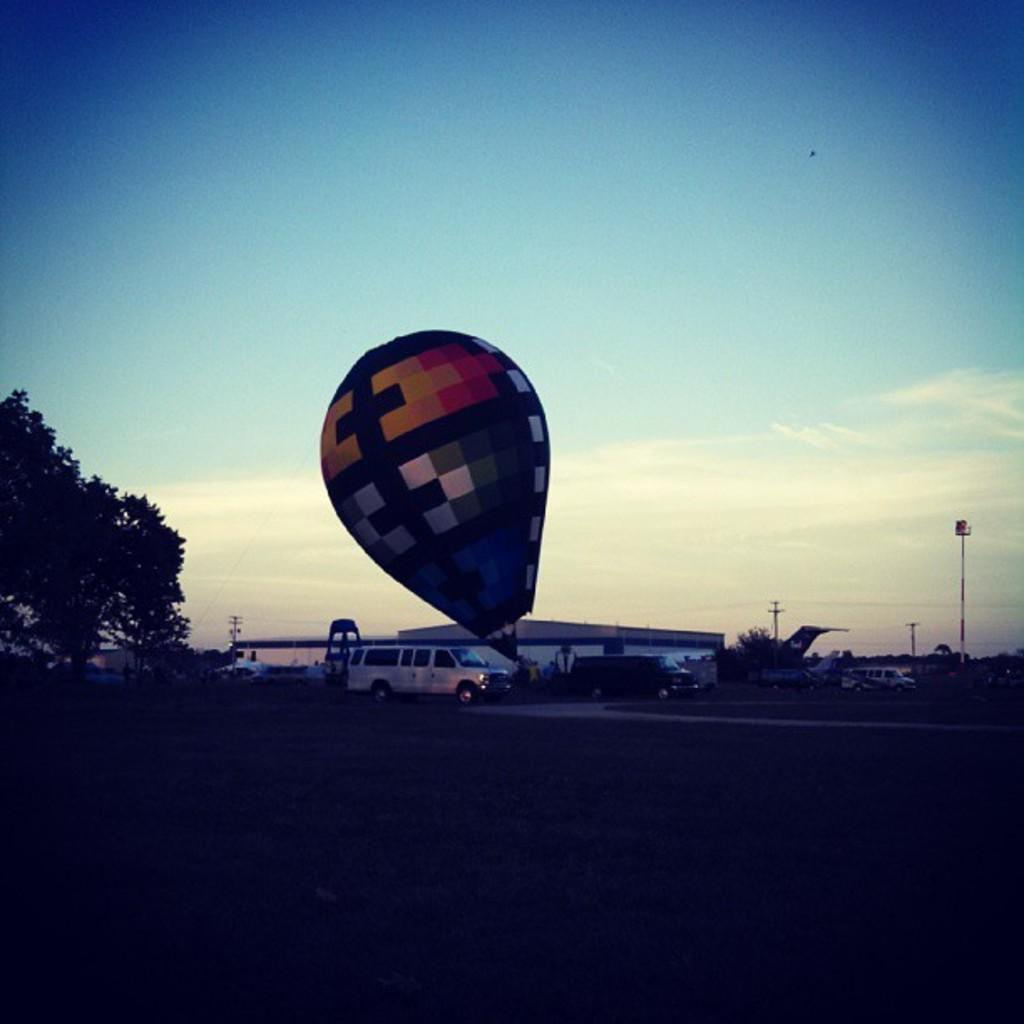What type of natural elements can be seen in the image? There are trees in the image. What man-made objects are present in the image? There are vehicles and a hot air balloon in the image. What structures can be seen in the background of the image? There are houses and poles in the background of the image. What is visible in the sky in the image? There are clouds in the background of the image. What type of sail can be seen on the hot air balloon in the image? There is no sail present on the hot air balloon in the image; it is powered by hot air. What curve can be observed in the image? There is no specific curve mentioned in the provided facts, so it cannot be determined from the image. 